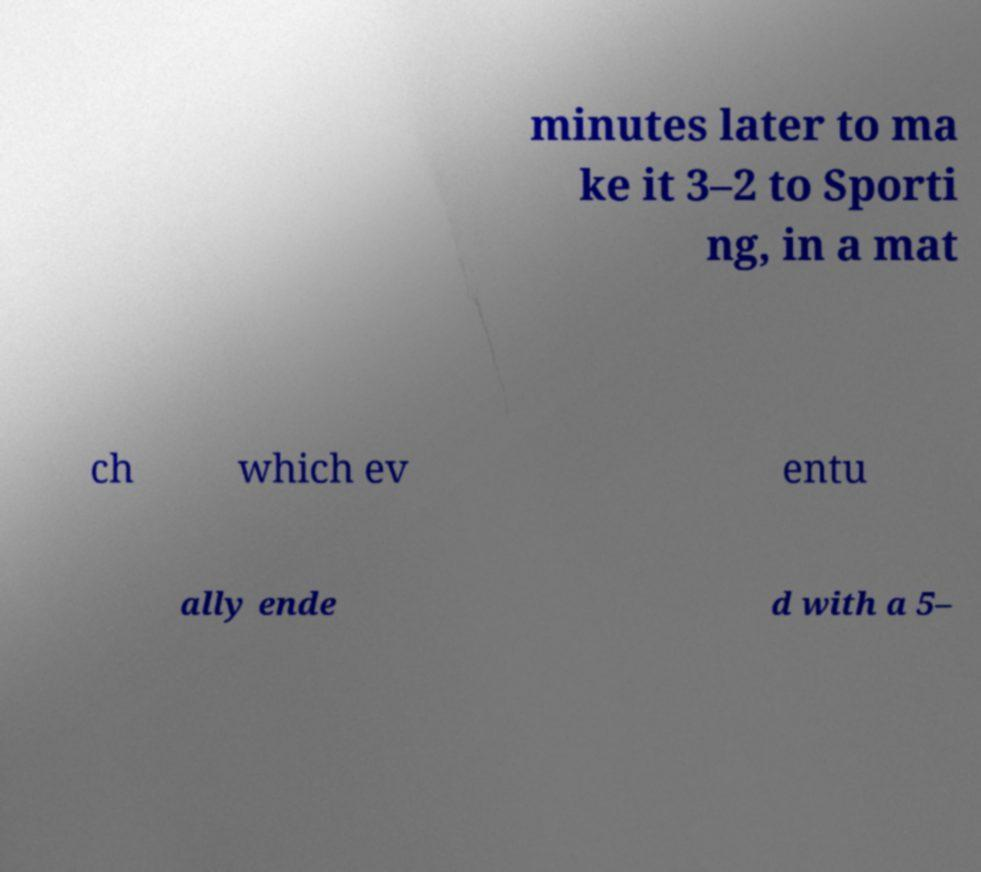Can you read and provide the text displayed in the image?This photo seems to have some interesting text. Can you extract and type it out for me? minutes later to ma ke it 3–2 to Sporti ng, in a mat ch which ev entu ally ende d with a 5– 